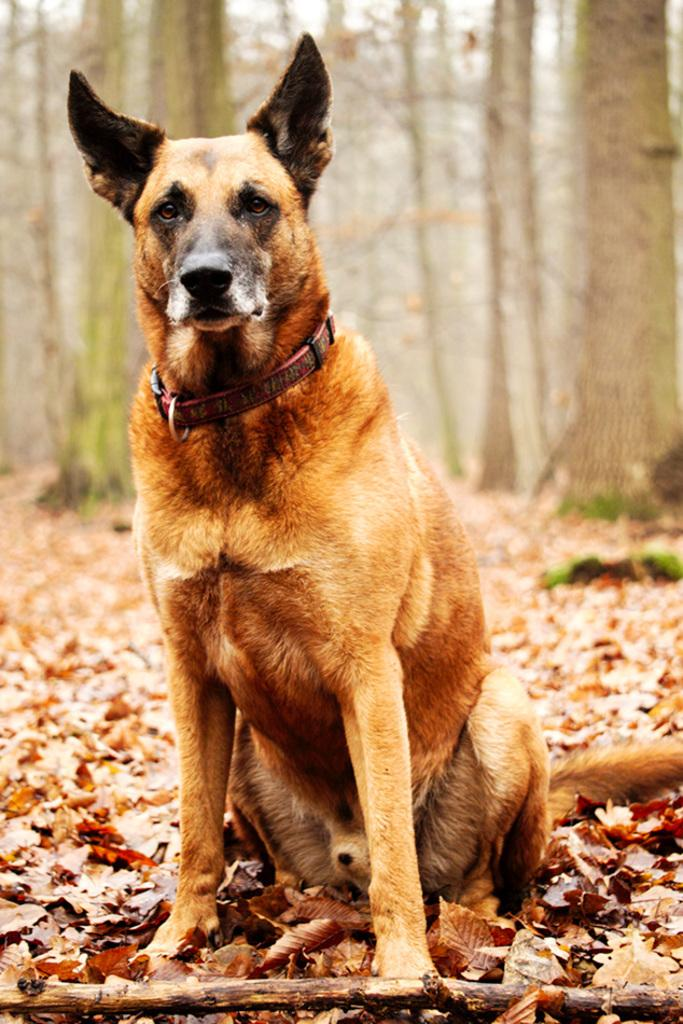Where was the image taken? The image was taken in the woods. What can be seen in the foreground of the image? There are dry leaves and a stick in the foreground of the image. What animal is present in the foreground of the image? There is a dog in the foreground of the image. What can be seen in the background of the image? There are trees in the background of the image. What type of pleasure can be seen in the image? There is no pleasure present in the image; it is a photograph of a dog, dry leaves, a stick, and trees in the woods. Can you tell me how many cannons are visible in the image? There are no cannons present in the image. 